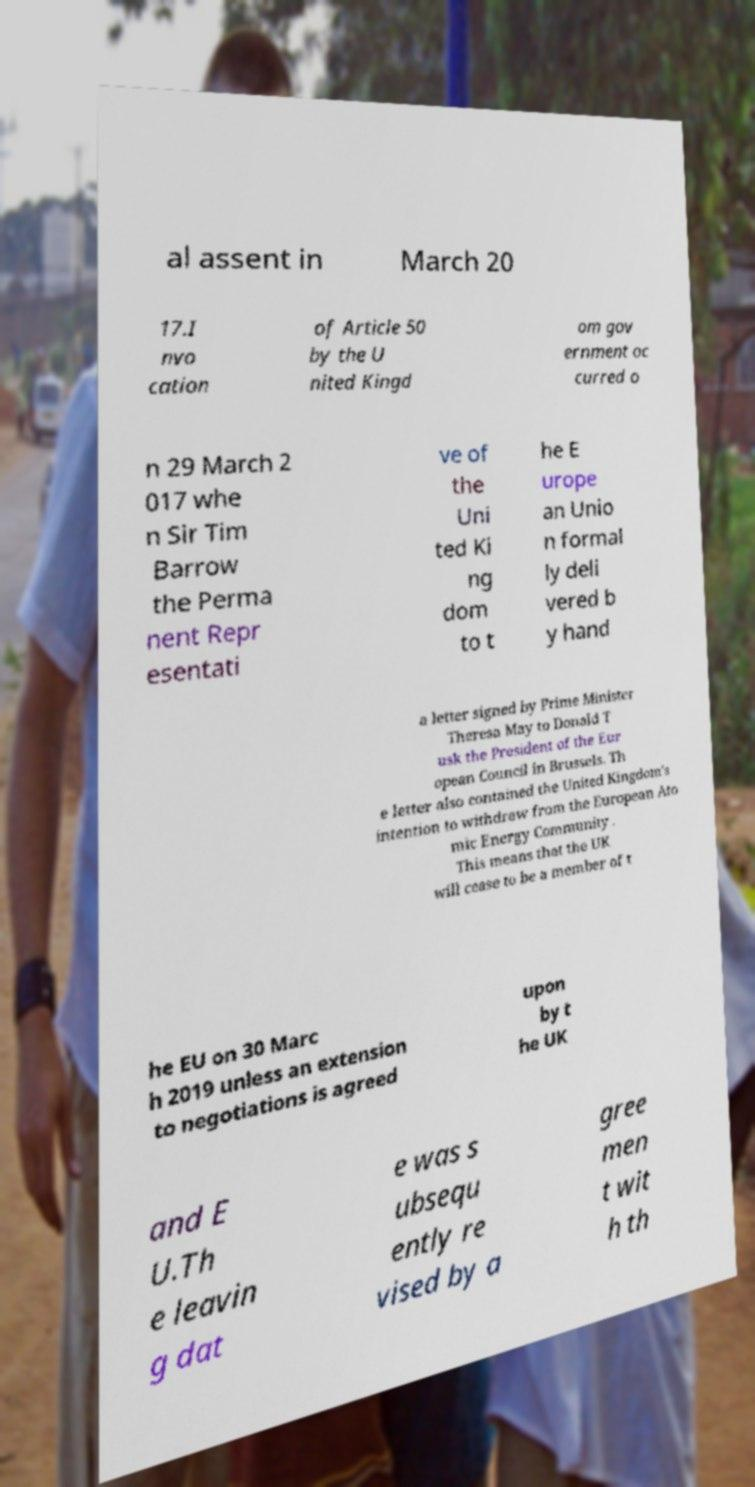Can you accurately transcribe the text from the provided image for me? al assent in March 20 17.I nvo cation of Article 50 by the U nited Kingd om gov ernment oc curred o n 29 March 2 017 whe n Sir Tim Barrow the Perma nent Repr esentati ve of the Uni ted Ki ng dom to t he E urope an Unio n formal ly deli vered b y hand a letter signed by Prime Minister Theresa May to Donald T usk the President of the Eur opean Council in Brussels. Th e letter also contained the United Kingdom's intention to withdraw from the European Ato mic Energy Community . This means that the UK will cease to be a member of t he EU on 30 Marc h 2019 unless an extension to negotiations is agreed upon by t he UK and E U.Th e leavin g dat e was s ubsequ ently re vised by a gree men t wit h th 